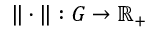Convert formula to latex. <formula><loc_0><loc_0><loc_500><loc_500>\| \cdot \| \colon G \to \mathbb { R _ { + } }</formula> 